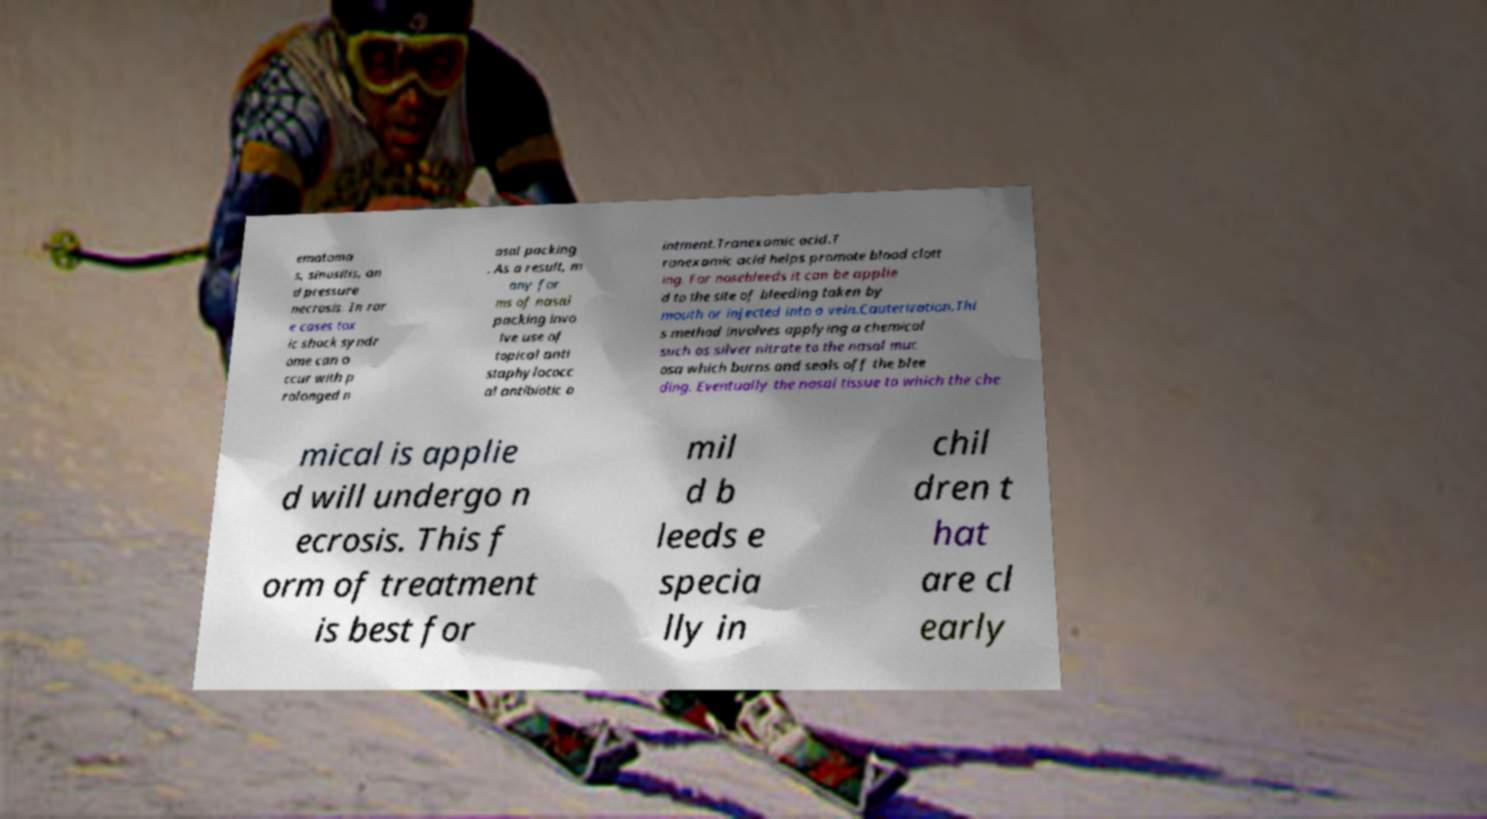For documentation purposes, I need the text within this image transcribed. Could you provide that? ematoma s, sinusitis, an d pressure necrosis. In rar e cases tox ic shock syndr ome can o ccur with p rolonged n asal packing . As a result, m any for ms of nasal packing invo lve use of topical anti staphylococc al antibiotic o intment.Tranexamic acid.T ranexamic acid helps promote blood clott ing. For nosebleeds it can be applie d to the site of bleeding taken by mouth or injected into a vein.Cauterization.Thi s method involves applying a chemical such as silver nitrate to the nasal muc osa which burns and seals off the blee ding. Eventually the nasal tissue to which the che mical is applie d will undergo n ecrosis. This f orm of treatment is best for mil d b leeds e specia lly in chil dren t hat are cl early 